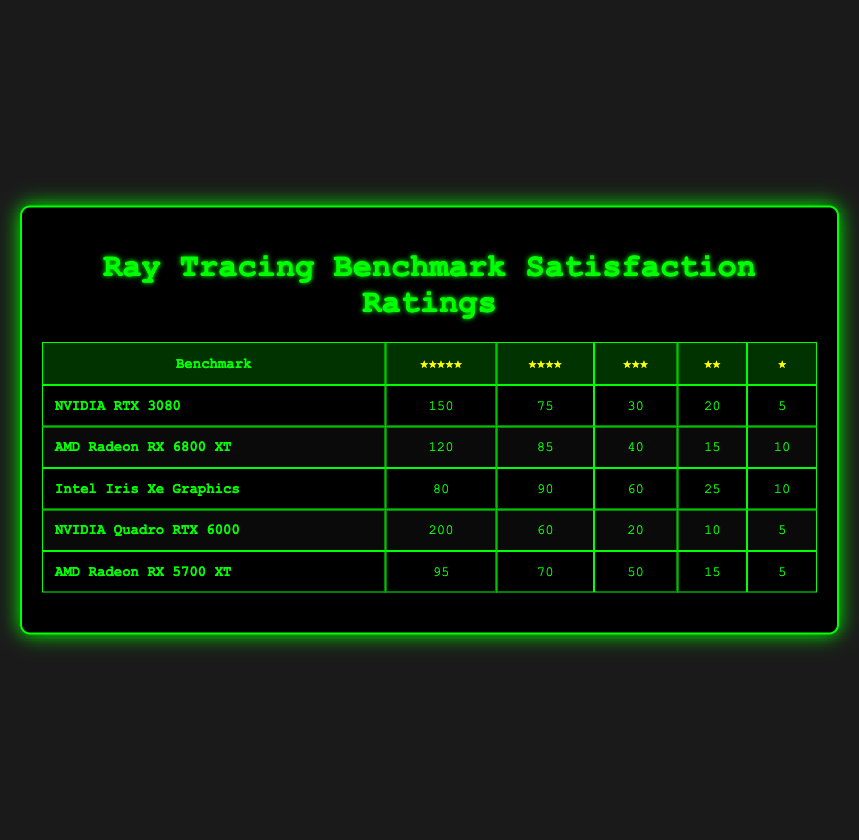What is the satisfaction rating for the NVIDIA RTX 3080 at 5 stars? The table indicates that the satisfaction rating for the NVIDIA RTX 3080 at 5 stars is 150.
Answer: 150 Which benchmark received the highest number of 4-star ratings? The NVIDIA RTX 3080 received 75 4-star ratings, AMD Radeon RX 6800 XT received 85, Intel Iris Xe Graphics received 90, NVIDIA Quadro RTX 6000 received 60, and AMD Radeon RX 5700 XT received 70. Therefore, the Intel Iris Xe Graphics received the highest number with 90.
Answer: Intel Iris Xe Graphics How many total ratings (all star categories) were provided for the NVIDIA Quadro RTX 6000? To find the total ratings for the NVIDIA Quadro RTX 6000, I add the number of ratings from all categories: 200 (5 stars) + 60 (4 stars) + 20 (3 stars) + 10 (2 stars) + 5 (1 star) = 295.
Answer: 295 Is the total number of 5-star ratings across all benchmarks greater than 500? The total number of 5-star ratings is 150 (RTX 3080) + 120 (Radeon RX 6800 XT) + 80 (Iris Xe Graphics) + 200 (Quadro RTX 6000) + 95 (Radeon RX 5700 XT) = 645. 645 is greater than 500, so the statement is true.
Answer: Yes What is the average number of 1-star ratings across all benchmarks? The number of 1-star ratings for each benchmark is: 5 (RTX 3080), 10 (Radeon RX 6800 XT), 10 (Iris Xe Graphics), 5 (Quadro RTX 6000), and 5 (Radeon RX 5700 XT). Summing these gives 5 + 10 + 10 + 5 + 5 = 35. Since there are 5 benchmarks, the average is 35 / 5 = 7.
Answer: 7 Which benchmark has the lowest number of 2-star ratings? The numbers of 2-star ratings are: 20 (RTX 3080), 15 (Radeon RX 6800 XT), 25 (Iris Xe Graphics), 10 (Quadro RTX 6000), and 15 (Radeon RX 5700 XT). The Quadro RTX 6000 has the lowest with 10 ratings.
Answer: NVIDIA Quadro RTX 6000 What is the difference in 3-star ratings between AMD Radeon RX 6800 XT and Intel Iris Xe Graphics? The AMD Radeon RX 6800 XT has 40 ratings while the Intel Iris Xe Graphics has 60 ratings. The difference is 60 - 40 = 20.
Answer: 20 Did the AMD Radeon RX 5700 XT receive more 4-star ratings than the Intel Iris Xe Graphics? The AMD Radeon RX 5700 XT received 70 ratings and the Intel Iris Xe Graphics received 90 ratings. Since 70 is less than 90, the statement is false.
Answer: No What is the total number of 4-star ratings among all benchmarks? The total number of 4-star ratings is calculated as follows: 75 (RTX 3080) + 85 (Radeon RX 6800 XT) + 90 (Iris Xe Graphics) + 60 (Quadro RTX 6000) + 70 (Radeon RX 5700 XT) = 380.
Answer: 380 